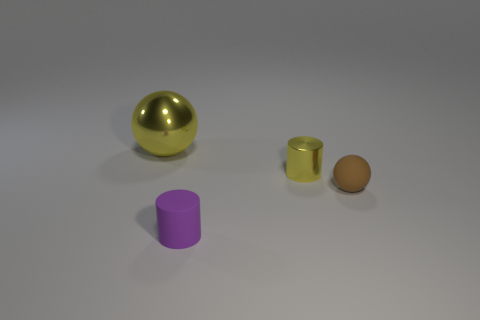Add 3 small metal balls. How many objects exist? 7 Subtract all purple cylinders. Subtract all rubber cubes. How many objects are left? 3 Add 2 matte cylinders. How many matte cylinders are left? 3 Add 1 small blue matte cylinders. How many small blue matte cylinders exist? 1 Subtract 0 red spheres. How many objects are left? 4 